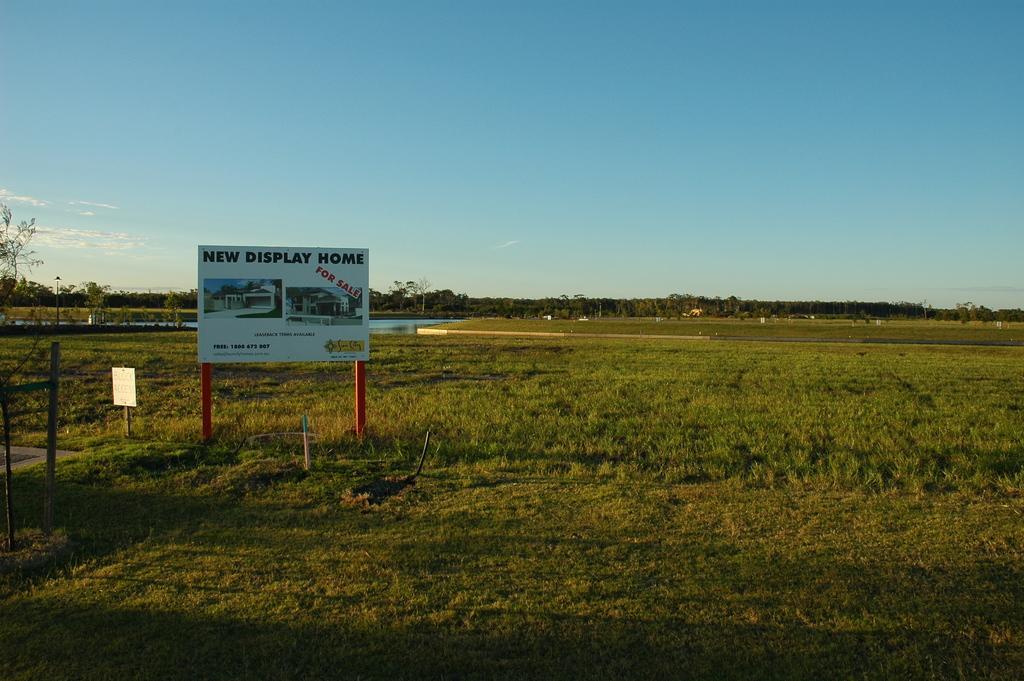Please provide a concise description of this image. Here on the ground we can see grass,poles and a board. In the background there are trees,water,poles,houses and clouds in the sky. 